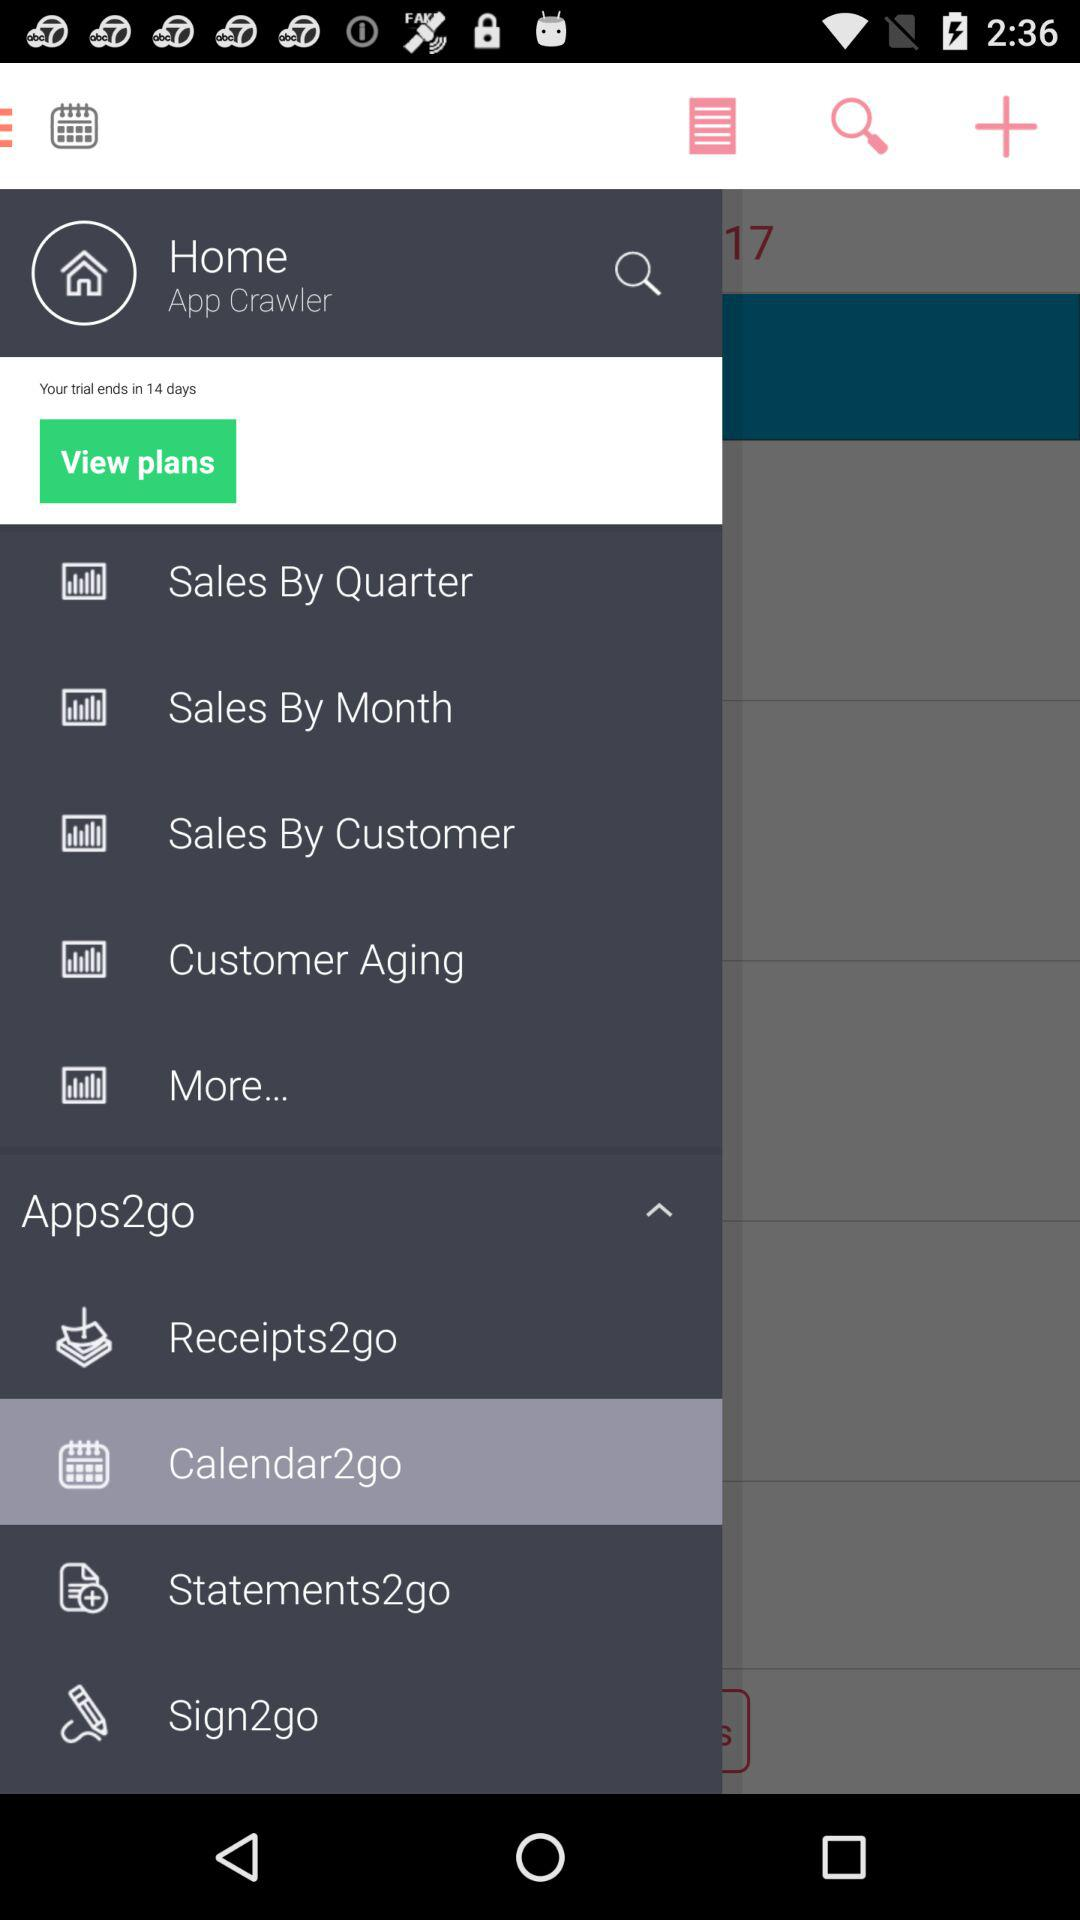What is the user name? The user name is App Crawler. 